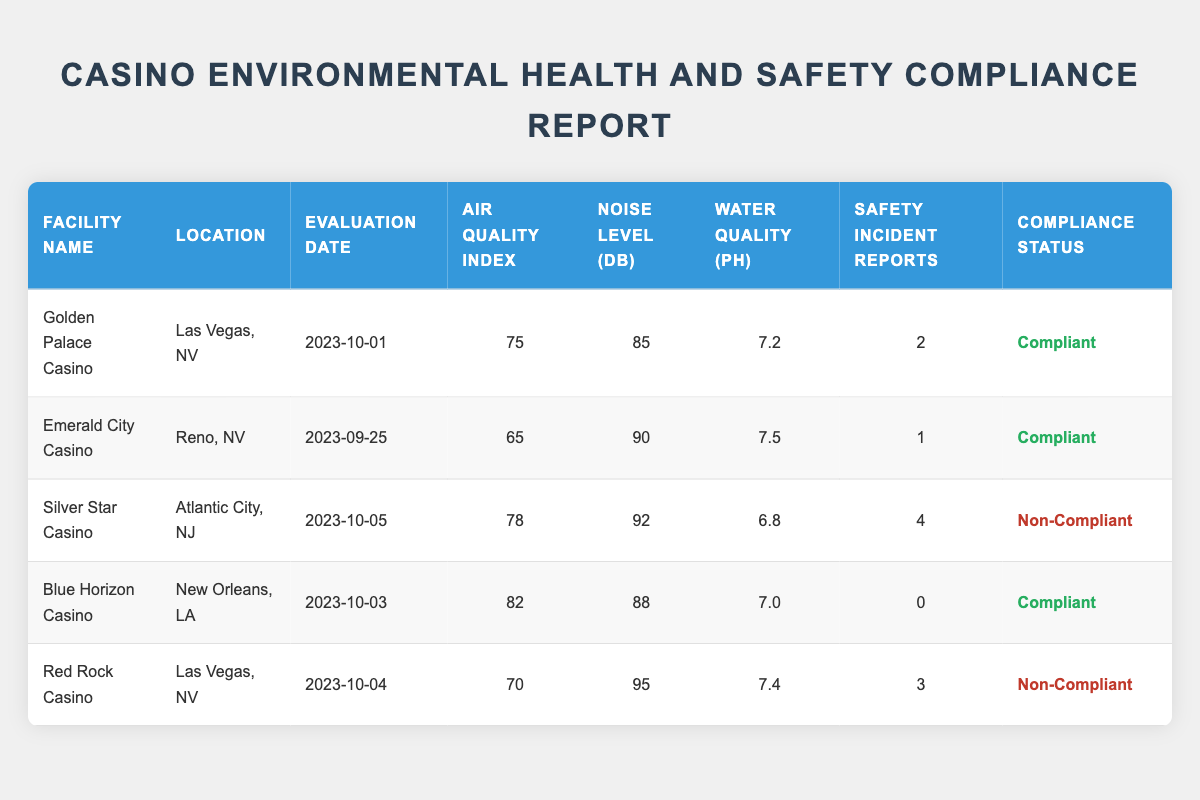What is the compliance status of Blue Horizon Casino? The table indicates that Blue Horizon Casino has a compliance status of "Compliant" as shown in the last column of its row.
Answer: Compliant Which facility has the highest Noise Level in dB? By examining the Noise Level column, Red Rock Casino has the highest value of 95 dB.
Answer: Red Rock Casino What is the average Air Quality Index of the compliant facilities? The compliant facilities are Golden Palace Casino, Emerald City Casino, and Blue Horizon Casino. Their Air Quality Index values are 75, 65, and 82 respectively. The sum is 75 + 65 + 82 = 222, divided by 3 gives an average of 74.
Answer: 74 Does Silver Star Casino comply with the environmental health and safety regulations? The table shows that Silver Star Casino has a compliance status of "Non-Compliant".
Answer: No How many total Safety Incident Reports were recorded across all facilities? Adding the Safety Incident Reports from each facility: 2 (Golden Palace) + 1 (Emerald City) + 4 (Silver Star) + 0 (Blue Horizon) + 3 (Red Rock), the total is 10 incidents.
Answer: 10 Which facility has the lowest Water Quality pH? The pH values are listed as 7.2 (Golden Palace), 7.5 (Emerald City), 6.8 (Silver Star), 7.0 (Blue Horizon), and 7.4 (Red Rock). Silver Star Casino has the lowest pH value of 6.8.
Answer: Silver Star Casino Are there any facilities with a Noise Level greater than 90 dB? Checking the Noise Level column, both Red Rock Casino (95 dB) and Silver Star Casino (92 dB) exceed 90 dB.
Answer: Yes What is the difference in Air Quality Index between compliant and non-compliant facilities? The compliant facilities have an Air Quality Index of 75 (Golden Palace), 65 (Emerald City), and 82 (Blue Horizon) totaling 222. The non-compliant facilities are Silver Star (78) and Red Rock (70) totaling 148. The average for compliant is 74 and non-compliant is 74 (average of both).
Answer: 0 